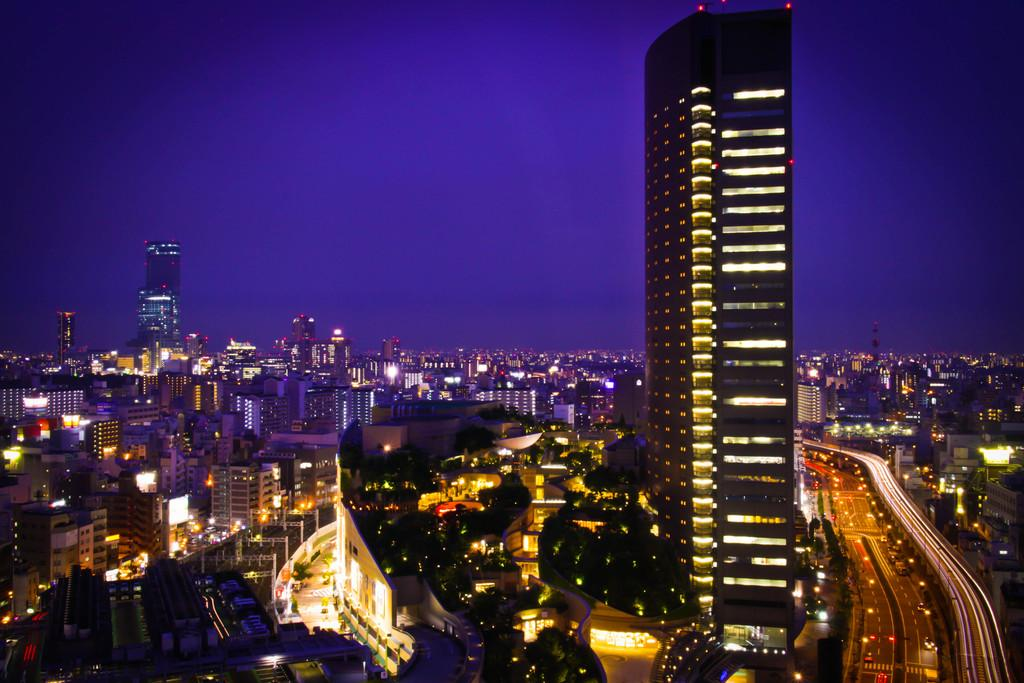What type of structures can be seen in the image? There are buildings in the image. What can be seen illuminating the scene in the image? There are lights visible in the image. What is present on the right side of the road in the image? There are vehicles on the right side of the road in the image. What type of animal is present on the edge of the image? There is no animal present on the edge of the image. What team is responsible for maintaining the lights in the image? The image does not provide information about who is responsible for maintaining the lights. 